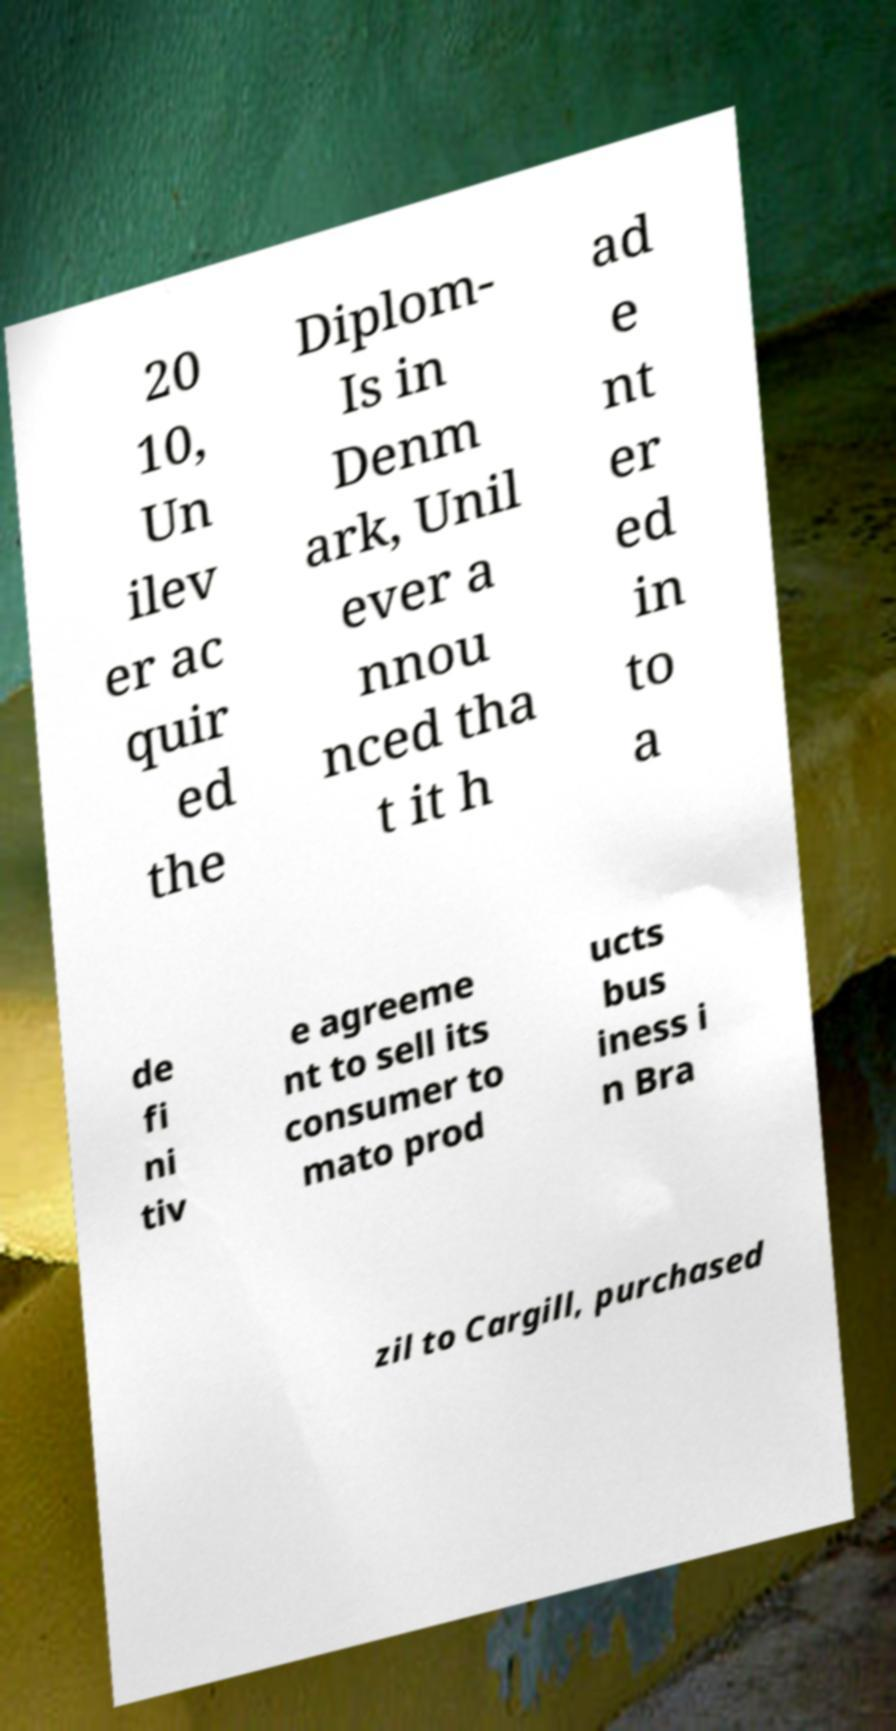Please read and relay the text visible in this image. What does it say? 20 10, Un ilev er ac quir ed the Diplom- Is in Denm ark, Unil ever a nnou nced tha t it h ad e nt er ed in to a de fi ni tiv e agreeme nt to sell its consumer to mato prod ucts bus iness i n Bra zil to Cargill, purchased 